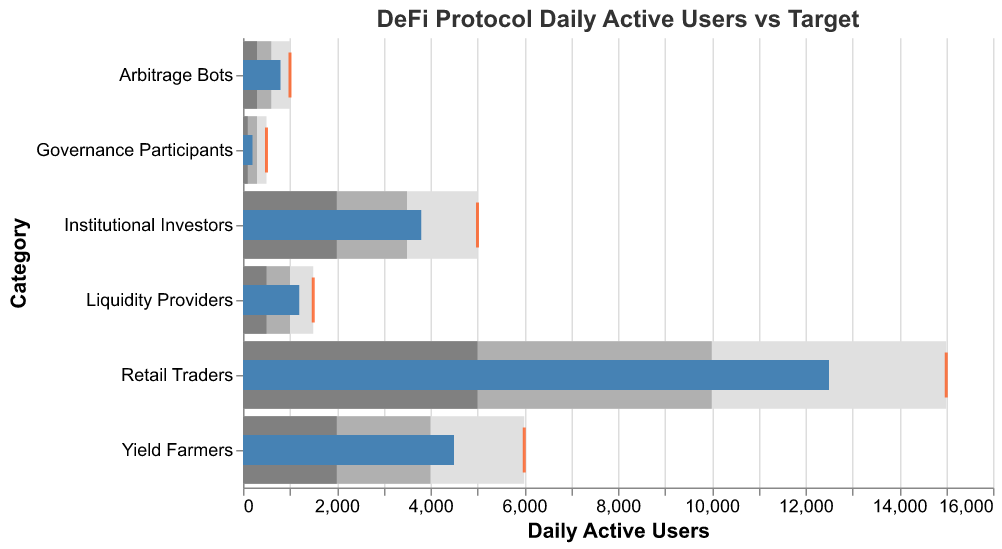What is the title of the chart? The title is typically displayed at the top of the chart and provides a brief description of what the chart represents. In this case, it reads "DeFi Protocol Daily Active Users vs Target".
Answer: DeFi Protocol Daily Active Users vs Target Which category has the highest number of actual daily active users? By examining the length of the blue bars that represent the actual number of daily active users, the longest bar belongs to "Retail Traders".
Answer: Retail Traders How much is the target number of daily active users for Institutional Investors? The target number of daily active users is shown by the red tick mark on the chart. For "Institutional Investors", the red tick mark is aligned with the value of 5000.
Answer: 5000 How does the actual number of daily active users for Yield Farmers compare to their target? By looking at the blue bar and the red tick mark for "Yield Farmers", the actual number (4500) is less than the target number (6000).
Answer: Less than For which category is the actual number of users closest to the target? By comparing the blue bars to the red tick marks, "Arbitrage Bots" has the actual number (800) closest to the target (1000) as the difference is only 200.
Answer: Arbitrage Bots Which user category has the lowest actual daily active users, and what is the number? The shortest blue bar represents the lowest actual daily active users, which is for "Governance Participants" with 200 users.
Answer: Governance Participants, 200 What is the range of target users for Liquidity Providers, and how does it compare to the actual value? The target range for "Liquidity Providers" is from 500 to 1500. The actual number of daily active users (1200) is within this range.
Answer: Within range By how much do the actual daily active users for Retail Traders fall short of the target? The difference between the target (15000) and the actual number (12500) for Retail Traders is calculated as 15000 - 12500 = 2500.
Answer: 2500 Which user type exceeds its lower bound of range 1 but falls short of its target? Comparing the blue bars (actual values) with the first range values and target (red tick marks), "Yield Farmers" (4500) exceeds its lower bound of range 1 (2000) and range 2 (4000) but falls short of its target (6000).
Answer: Yield Farmers 